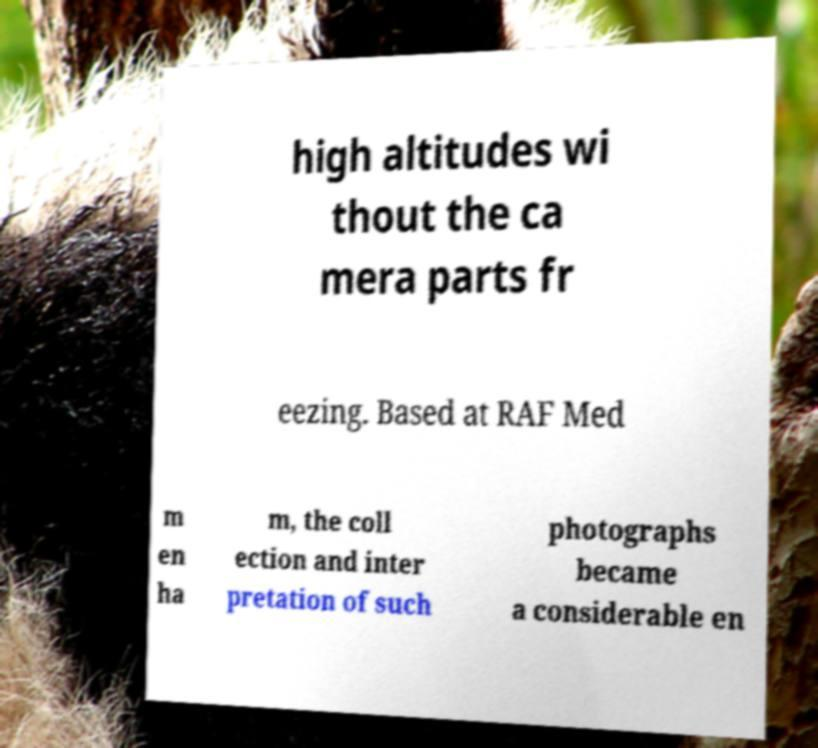Please read and relay the text visible in this image. What does it say? high altitudes wi thout the ca mera parts fr eezing. Based at RAF Med m en ha m, the coll ection and inter pretation of such photographs became a considerable en 